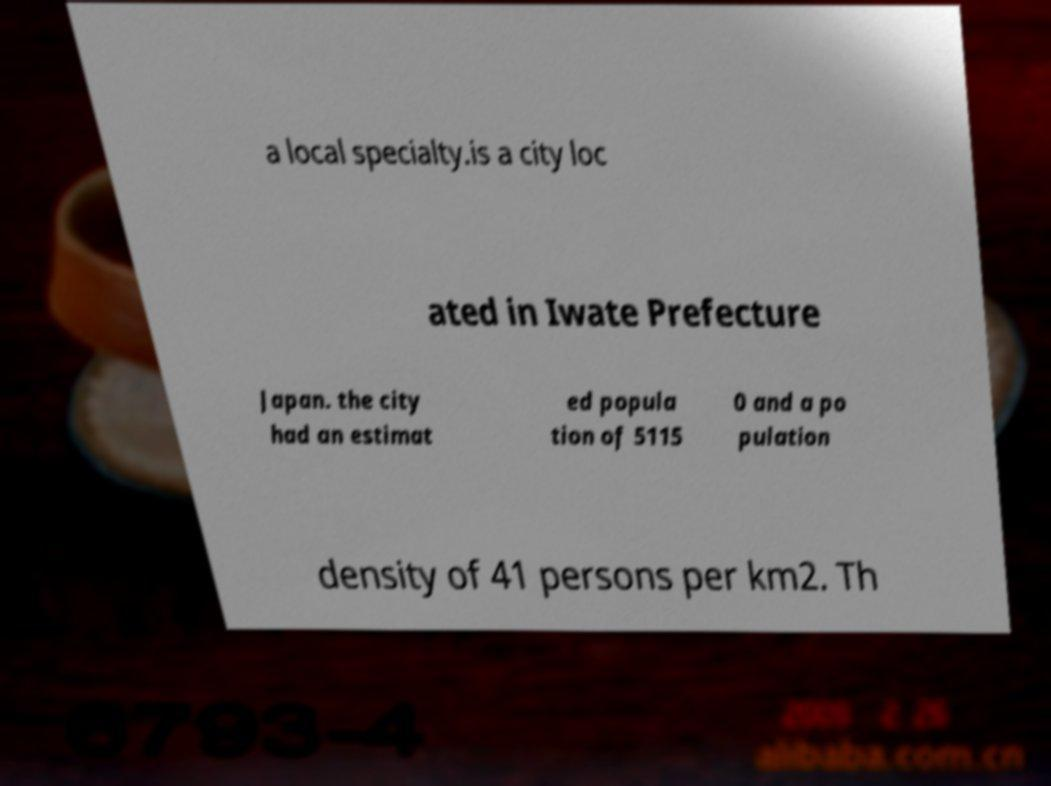Could you assist in decoding the text presented in this image and type it out clearly? a local specialty.is a city loc ated in Iwate Prefecture Japan. the city had an estimat ed popula tion of 5115 0 and a po pulation density of 41 persons per km2. Th 